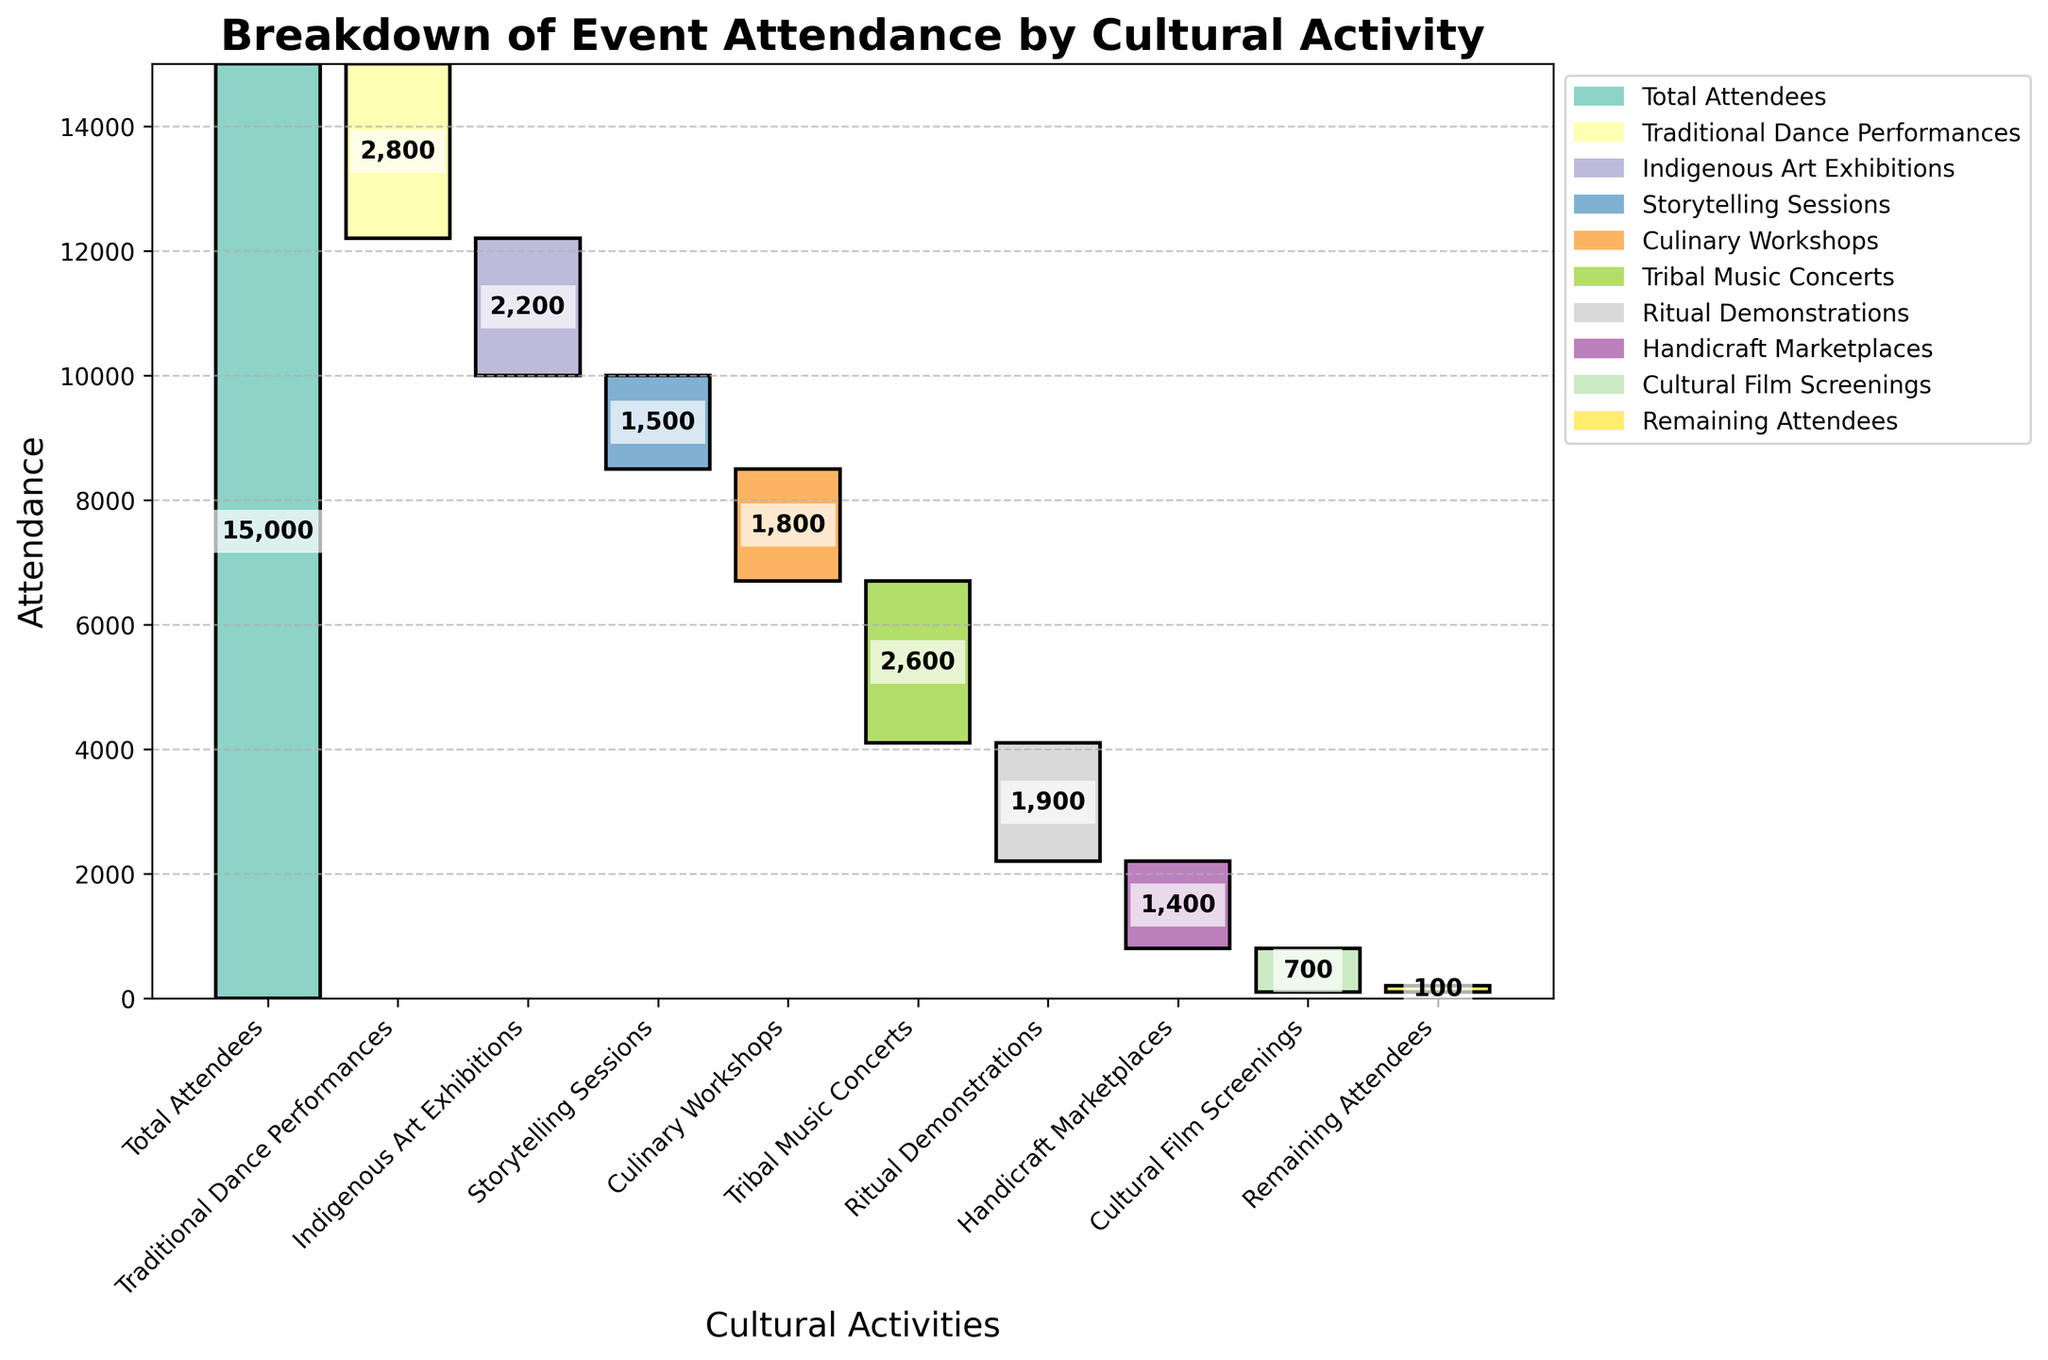What is the title of the chart? The title is displayed at the top of the chart and helps us understand what the chart is about.
Answer: Breakdown of Event Attendance by Cultural Activity How many cultural activities are listed in the chart? Count the number of different cultural activities shown along the x-axis.
Answer: 9 Which cultural activity had the highest negative attendance? Identify the activity with the largest bar length in the negative direction.
Answer: Traditional Dance Performances What was the attendance for Culinary Workshops? Locate Culinary Workshops along the x-axis and read the value associated with its bar.
Answer: 1,800 What is the sum of attendees for both Tribal Music Concerts and Ritual Demonstrations? Add the attendance values for Tribal Music Concerts and Ritual Demonstrations: 2,600 + 1,900.
Answer: 4,500 Which cultural activity had the lowest negative attendance? Identify the activity with the smallest bar length in the negative direction.
Answer: Cultural Film Screenings How do the attendees of Indigenous Art Exhibitions compare to that of Handicraft Marketplaces? Look at the bar lengths for both activities and compare the numerical values. Indigenous Art Exhibitions had 2,200 attendees, while Handicraft Marketplaces had 1,400.
Answer: Indigenous Art Exhibitions had higher attendance What is the total attendance drop from the Traditional Dance Performances to the Storytelling Sessions? Calculate the cumulative drop by summing the attendance values of Traditional Dance Performances, Indigenous Art Exhibitions, and Storytelling Sessions: 2,800 + 2,200 + 1,500.
Answer: 6,500 What is the remaining attendance after considering all the cultural activities? Locate the endpoint of the waterfall where it indicates the remaining attendees.
Answer: 100 What percentage of the total attendees participated in Tribal Music Concerts? Divide the attendance of Tribal Music Concerts by the total attendees and multiply by 100 to get the percentage: (2,600 / 15,000) * 100.
Answer: 17.33% 